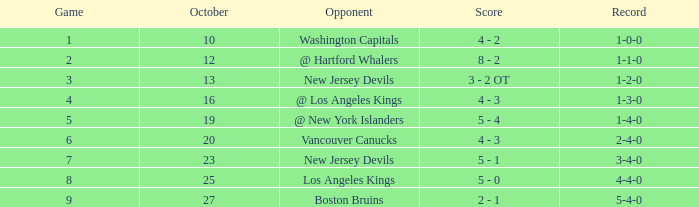In october, which game achieved the top score of 9? 27.0. Parse the full table. {'header': ['Game', 'October', 'Opponent', 'Score', 'Record'], 'rows': [['1', '10', 'Washington Capitals', '4 - 2', '1-0-0'], ['2', '12', '@ Hartford Whalers', '8 - 2', '1-1-0'], ['3', '13', 'New Jersey Devils', '3 - 2 OT', '1-2-0'], ['4', '16', '@ Los Angeles Kings', '4 - 3', '1-3-0'], ['5', '19', '@ New York Islanders', '5 - 4', '1-4-0'], ['6', '20', 'Vancouver Canucks', '4 - 3', '2-4-0'], ['7', '23', 'New Jersey Devils', '5 - 1', '3-4-0'], ['8', '25', 'Los Angeles Kings', '5 - 0', '4-4-0'], ['9', '27', 'Boston Bruins', '2 - 1', '5-4-0']]} 